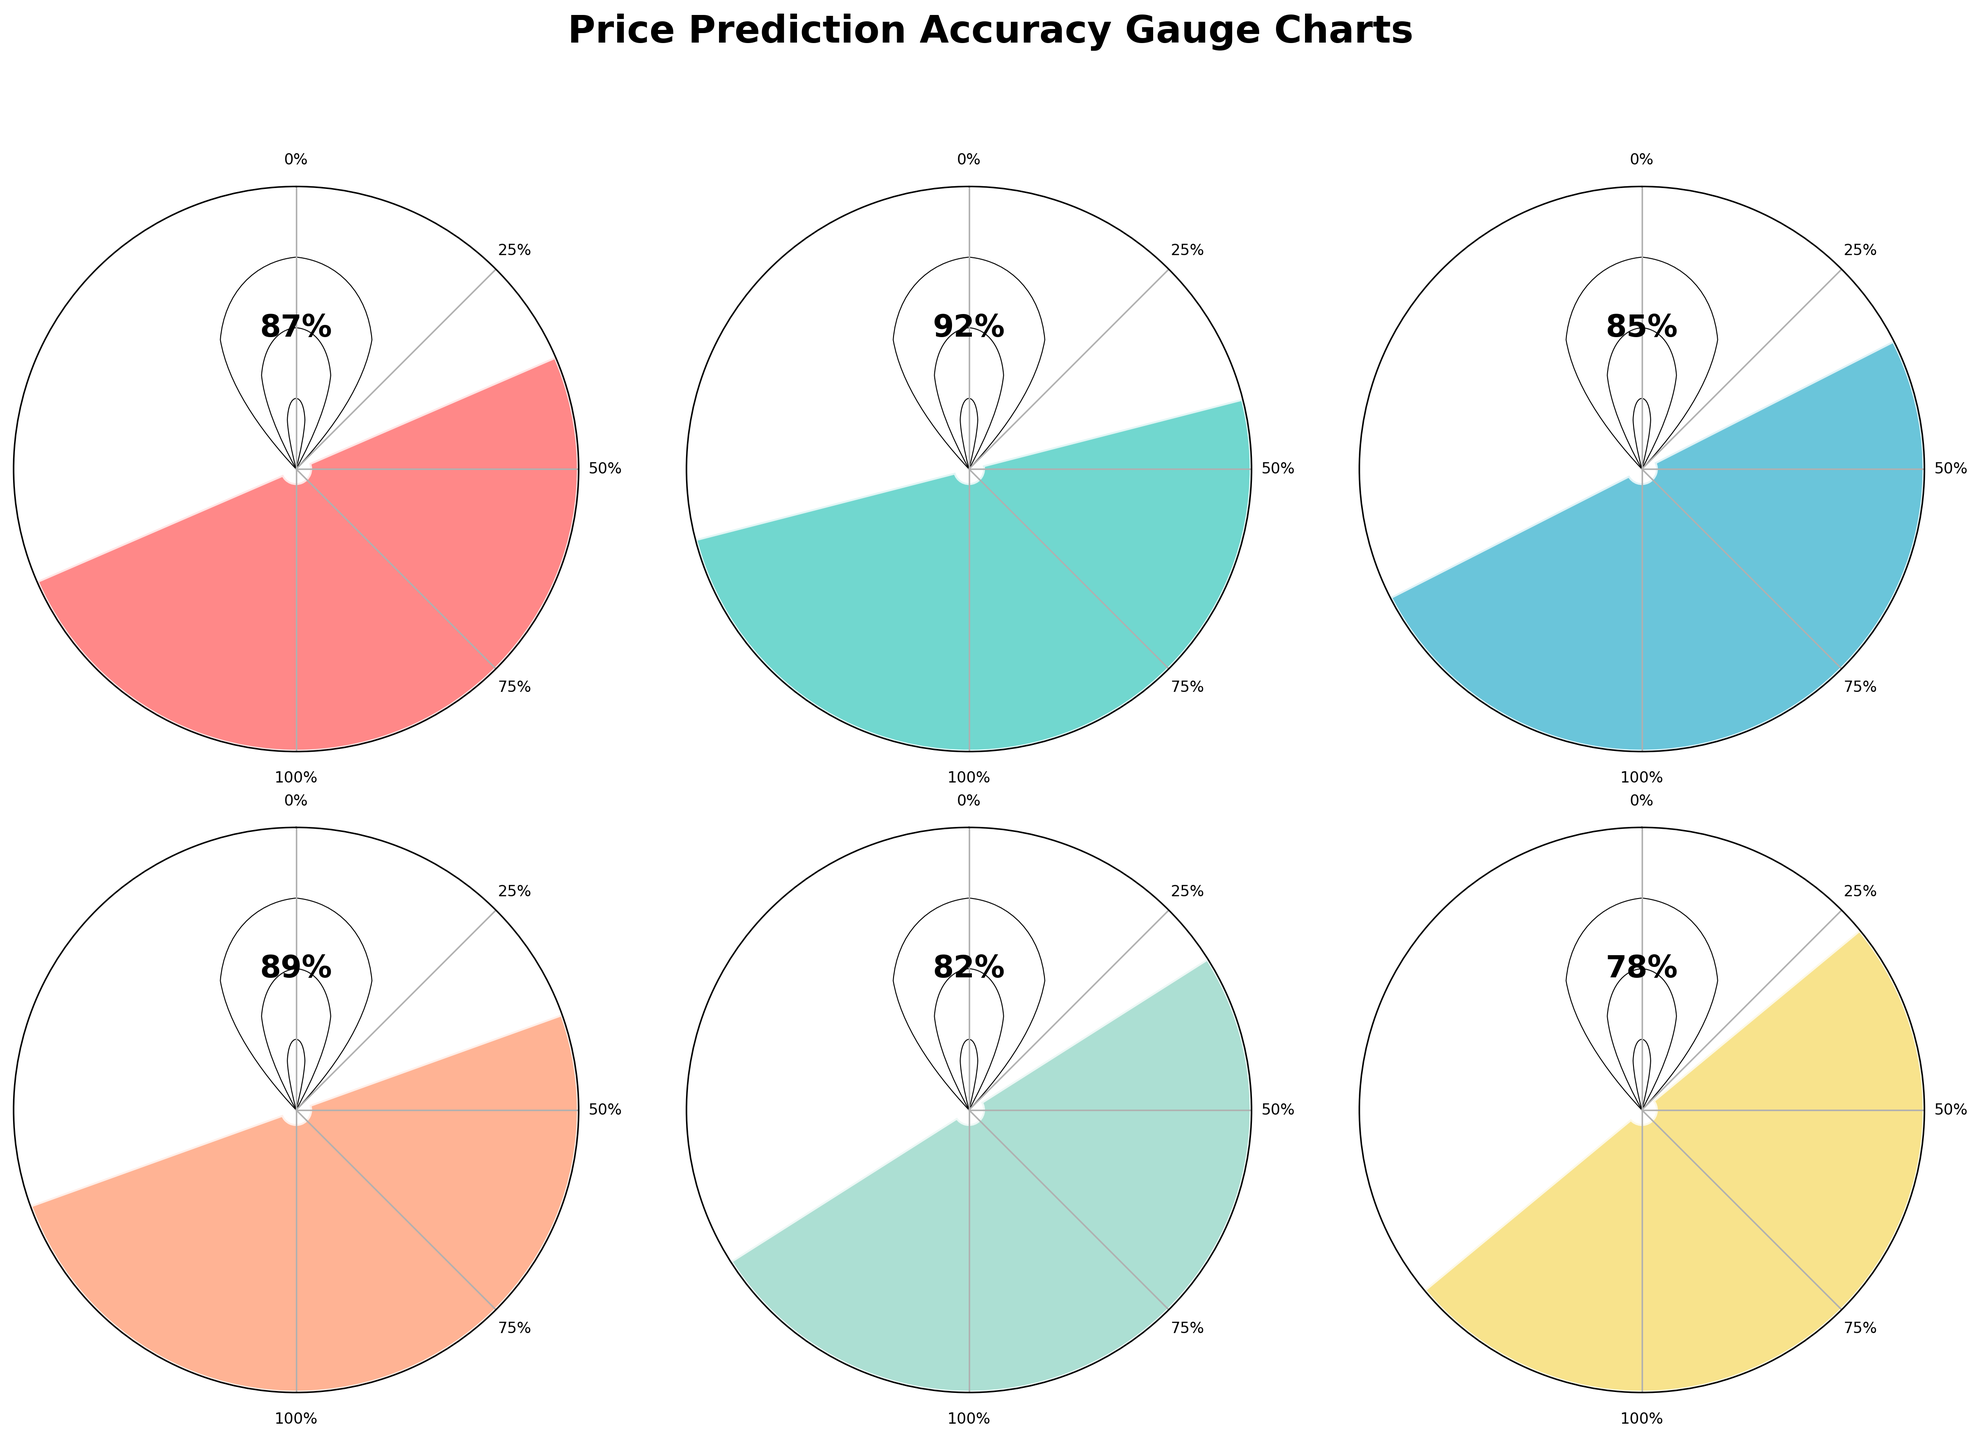What's the title of the figure? The title is usually located at the top of the figure. In this case, the title is present in bold and indicates the overall purpose of the figure.
Answer: Price Prediction Accuracy Gauge Charts What is the accuracy percentage for the Electronics Category? The accuracy percentage for each category is displayed within the respective gauge chart for that category. For Electronics Category, this percentage is listed inside the chart.
Answer: 92% Which category has the lowest accuracy? To determine the category with the lowest accuracy, compare all the accuracy percentages shown in the charts. The lowest percentage is the smallest value among them.
Answer: Seasonal Items How many gauge charts are displayed in total? Each category has its gauge chart, and the total number of gauge charts is the number of categories listed in the data. Count the individual charts to get the total.
Answer: 6 What’s the difference in accuracy between Home Goods and Grocery categories? The accuracy for Home Goods is 89% and for Grocery, it is 82%. Subtract the accuracy of the Grocery category from that of the Home Goods category to find the difference.
Answer: 7% Which category has greater accuracy: Clothing or Home Goods? Compare the accuracy percentages of the Clothing Category (85%) and Home Goods Category (89%).
Answer: Home Goods What color represents the Seasonal Items category in the charts? Each category is represented by a unique color. Examine the circle and bar colors within each gauge chart to determine the color for Seasonal Items.
Answer: Yellow How many categories have an accuracy of 85% or higher? Count the number of categories where the accuracy percentage shown in the charts is 85% or more.
Answer: 4 What is the overall accuracy percentage? The overall accuracy is displayed as one of the gauge charts. Locate this specific gauge chart to find the overall accuracy.
Answer: 87% Which three categories have the highest accuracy percentages? Compare the accuracy percentages of all categories and identify the top three highest percentages. The categories corresponding to these values are the ones with the highest accuracy.
Answer: Electronics, Home Goods, Overall Accuracy 